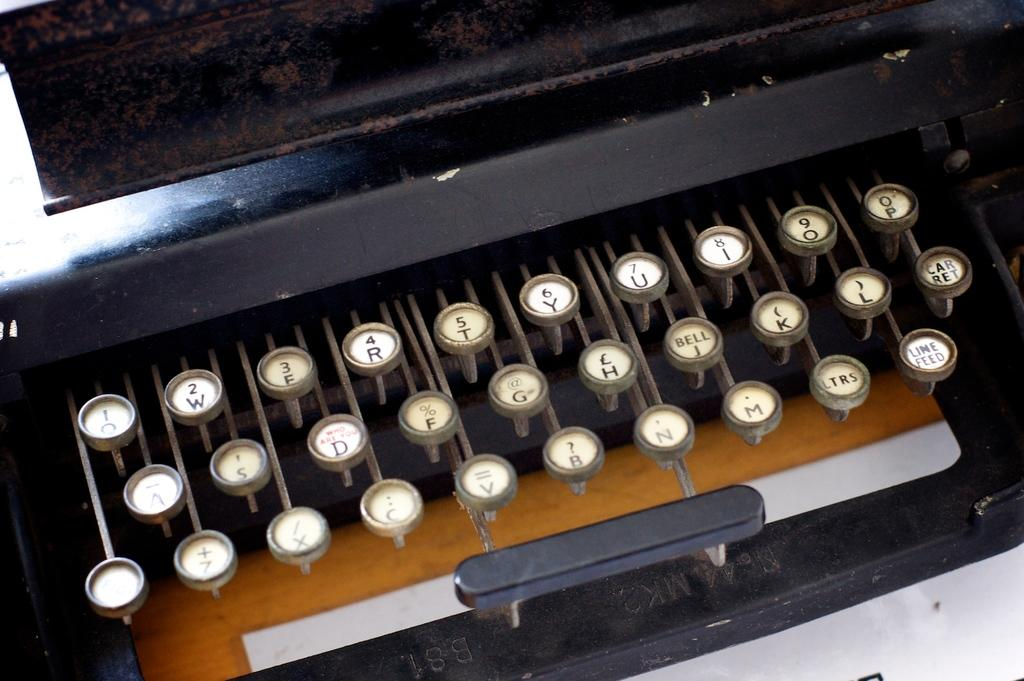<image>
Give a short and clear explanation of the subsequent image. An old keyboard shows the word Bell on the same button as the letter J. 